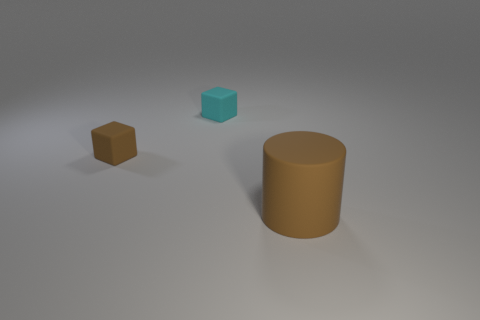How many tiny matte blocks have the same color as the large rubber object?
Provide a succinct answer. 1. How big is the object that is to the left of the small matte block behind the brown object to the left of the large rubber thing?
Give a very brief answer. Small. What number of metallic objects are either tiny gray cubes or cyan objects?
Keep it short and to the point. 0. There is a rubber block to the left of the small cyan matte object; what is its color?
Ensure brevity in your answer.  Brown. There is a rubber object that is the same size as the brown matte block; what shape is it?
Offer a very short reply. Cube. Does the big thing have the same color as the tiny object that is in front of the cyan rubber thing?
Give a very brief answer. Yes. What number of objects are matte blocks that are on the left side of the small cyan cube or tiny rubber cubes right of the brown rubber cube?
Your answer should be compact. 2. There is a cyan object that is the same size as the brown rubber cube; what is it made of?
Provide a short and direct response. Rubber. What number of other objects are the same material as the big brown thing?
Offer a terse response. 2. Is the shape of the brown matte thing to the left of the cylinder the same as the matte object that is right of the cyan object?
Keep it short and to the point. No. 